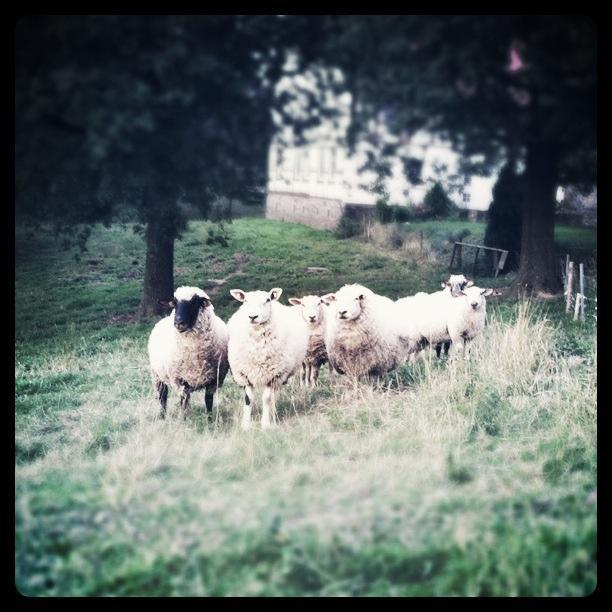How many sheep have black faces?
Give a very brief answer. 1. How many sheep are in the picture?
Give a very brief answer. 4. 